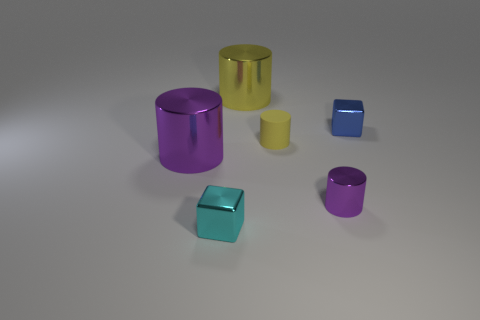Subtract all purple cylinders. How many were subtracted if there are1purple cylinders left? 1 Subtract all red cylinders. Subtract all gray spheres. How many cylinders are left? 4 Add 2 tiny yellow matte things. How many objects exist? 8 Subtract all cubes. How many objects are left? 4 Add 4 large purple metal cylinders. How many large purple metal cylinders exist? 5 Subtract 0 yellow balls. How many objects are left? 6 Subtract all tiny cyan metal balls. Subtract all purple objects. How many objects are left? 4 Add 4 purple metal cylinders. How many purple metal cylinders are left? 6 